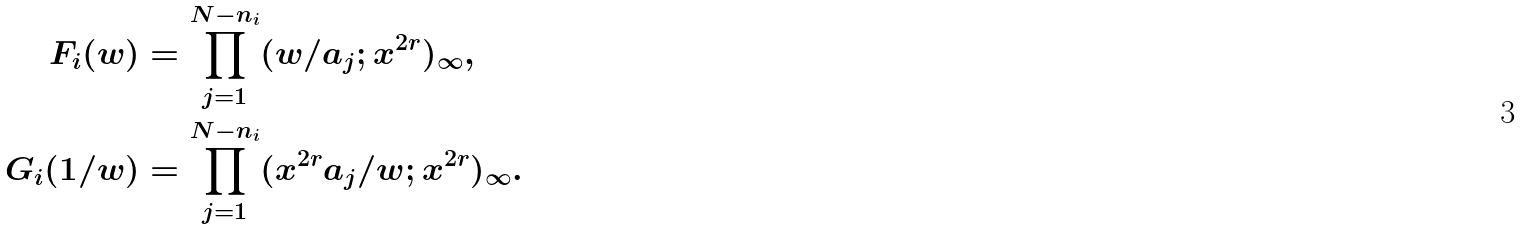<formula> <loc_0><loc_0><loc_500><loc_500>F _ { i } ( w ) & = \prod _ { j = 1 } ^ { N - n _ { i } } ( w / a _ { j } ; x ^ { 2 r } ) _ { \infty } , \\ G _ { i } ( 1 / w ) & = \prod _ { j = 1 } ^ { N - n _ { i } } ( x ^ { 2 r } a _ { j } / w ; x ^ { 2 r } ) _ { \infty } .</formula> 